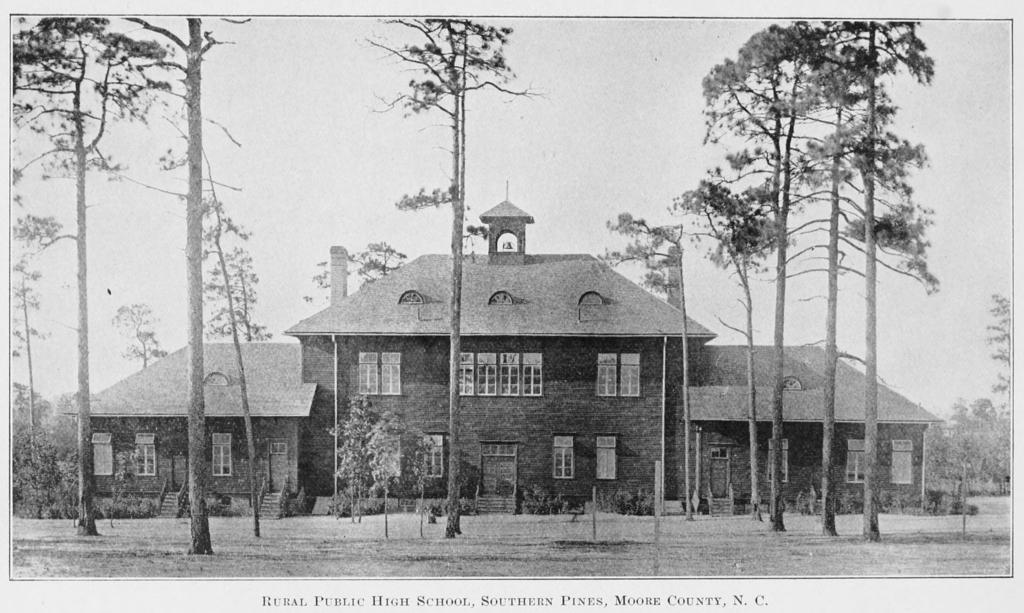Could you give a brief overview of what you see in this image? In this image we can a house, windows, plants, trees, also we can see the sky, and some text on the image. 